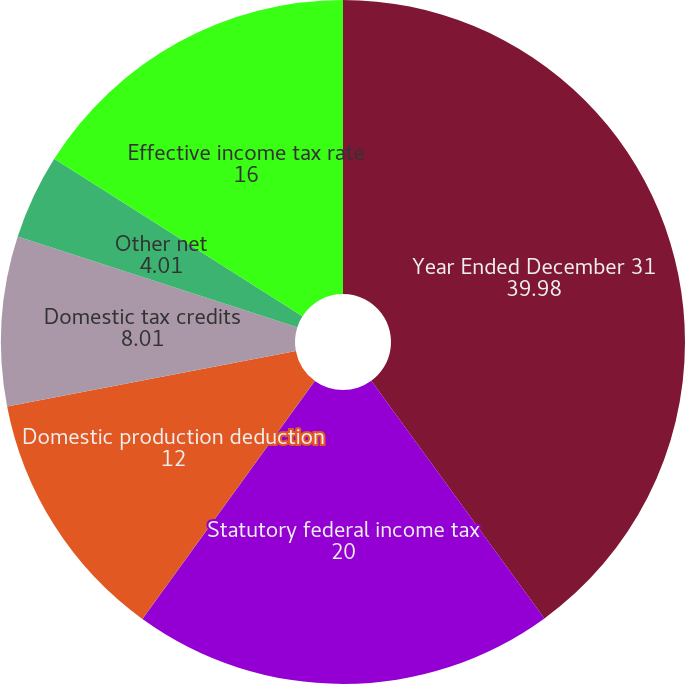Convert chart to OTSL. <chart><loc_0><loc_0><loc_500><loc_500><pie_chart><fcel>Year Ended December 31<fcel>Statutory federal income tax<fcel>State tax on commercial<fcel>Domestic production deduction<fcel>Domestic tax credits<fcel>Other net<fcel>Effective income tax rate<nl><fcel>39.98%<fcel>20.0%<fcel>0.01%<fcel>12.0%<fcel>8.01%<fcel>4.01%<fcel>16.0%<nl></chart> 